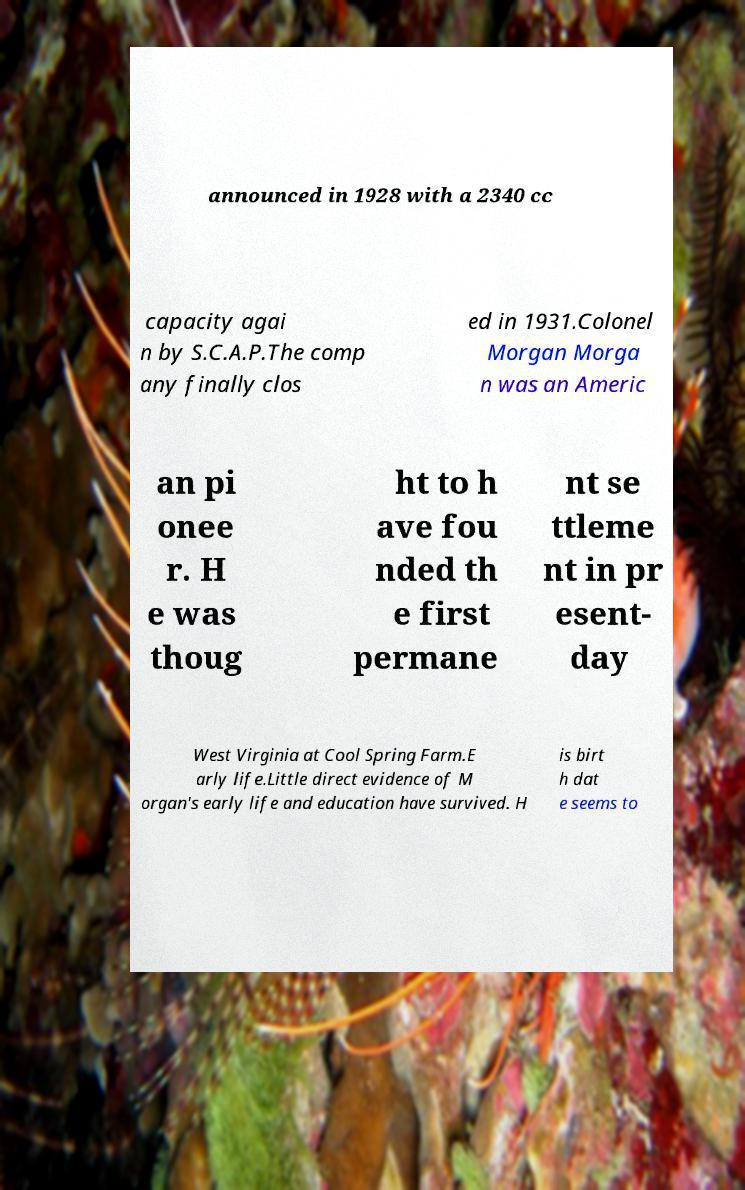What messages or text are displayed in this image? I need them in a readable, typed format. announced in 1928 with a 2340 cc capacity agai n by S.C.A.P.The comp any finally clos ed in 1931.Colonel Morgan Morga n was an Americ an pi onee r. H e was thoug ht to h ave fou nded th e first permane nt se ttleme nt in pr esent- day West Virginia at Cool Spring Farm.E arly life.Little direct evidence of M organ's early life and education have survived. H is birt h dat e seems to 